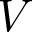Convert formula to latex. <formula><loc_0><loc_0><loc_500><loc_500>V</formula> 